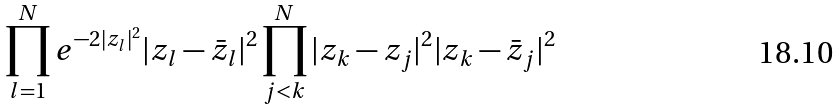Convert formula to latex. <formula><loc_0><loc_0><loc_500><loc_500>\prod _ { l = 1 } ^ { N } e ^ { - 2 | z _ { l } | ^ { 2 } } | z _ { l } - \bar { z } _ { l } | ^ { 2 } \prod _ { j < k } ^ { N } | z _ { k } - z _ { j } | ^ { 2 } | z _ { k } - \bar { z } _ { j } | ^ { 2 }</formula> 